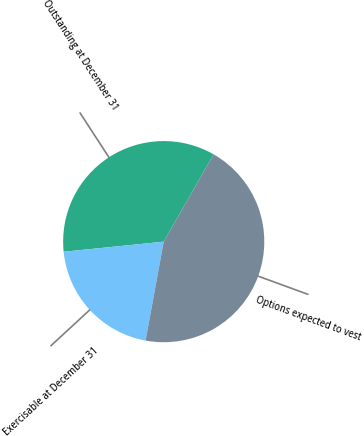Convert chart to OTSL. <chart><loc_0><loc_0><loc_500><loc_500><pie_chart><fcel>Outstanding at December 31<fcel>Exercisable at December 31<fcel>Options expected to vest<nl><fcel>34.87%<fcel>20.51%<fcel>44.62%<nl></chart> 